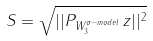<formula> <loc_0><loc_0><loc_500><loc_500>S = \sqrt { | | P _ { W ^ { \sigma - m o d e l } _ { 3 } } \, z | | ^ { 2 } }</formula> 